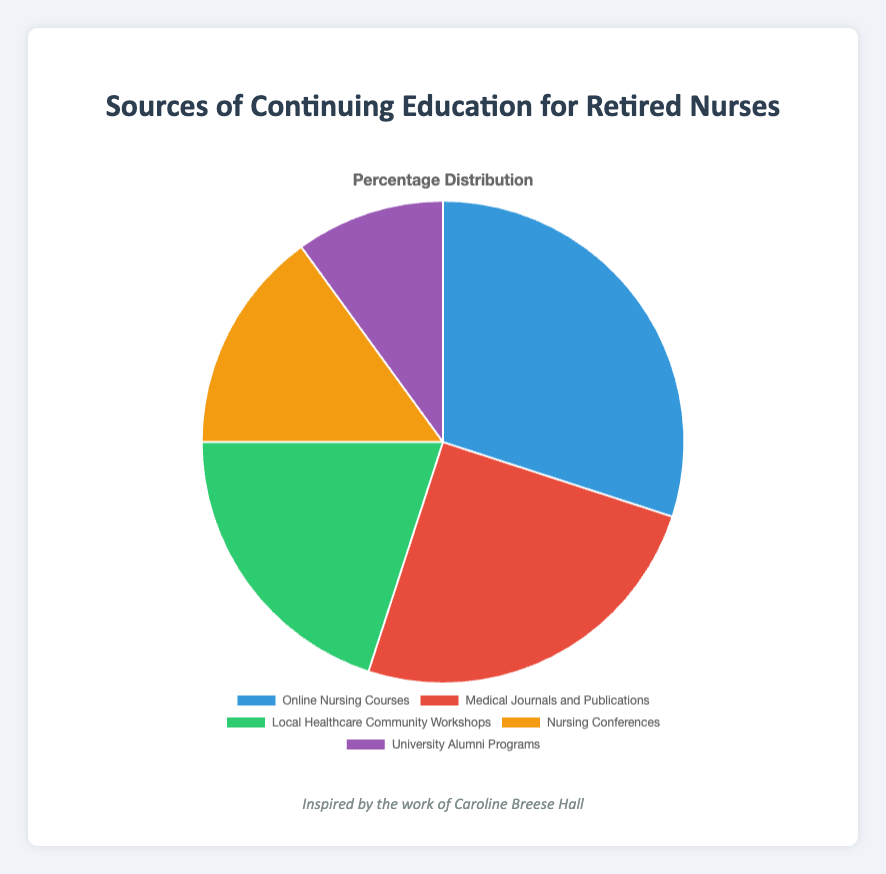What source has the highest percentage of continuing education for retired nurses? The source with the highest percentage can be identified by looking for the largest slice in the pie chart. "Online Nursing Courses" represents the largest segment with 30%.
Answer: Online Nursing Courses What is the percentage difference between "Online Nursing Courses" and "University Alumni Programs"? First, identify the percentages for both sources from the pie chart: "Online Nursing Courses" is 30% and "University Alumni Programs" is 10%. Subtract 10% from 30%, resulting in a difference of 20%.
Answer: 20% Which two sources combined have a total percentage of 35%? To find combinations that total 35%, look at the smaller segments. "Nursing Conferences" (15%) and "University Alumni Programs" (10%) combined make 25%. Combining "Medical Journals and Publications" (25%) with "University Alumni Programs" (10%) equals 35%.
Answer: Medical Journals and Publications and University Alumni Programs How much more popular are "Local Healthcare Community Workshops" compared to "Nursing Conferences"? From the pie chart, "Local Healthcare Community Workshops" is 20% and "Nursing Conferences" is 15%. Subtract 15% from 20% to get the difference of 5%.
Answer: 5% What color represents "Medical Journals and Publications"? The legend in the pie chart assigns colors to each category. The color next to "Medical Journals and Publications" is red.
Answer: Red What is the combined percentage of "Medical Journals and Publications" and "Online Nursing Courses"? Identify the percentages from the pie chart: "Medical Journals and Publications" is 25% and "Online Nursing Courses" is 30%. Summing these gives 55%.
Answer: 55% Which source occupies the smallest slice of the pie chart? The segment with the smallest percentage is the smallest slice in the pie chart. "University Alumni Programs" occupies the smallest slice with 10%.
Answer: University Alumni Programs Is the percentage of "Local Healthcare Community Workshops" more or less than "Medical Journals and Publications"? Comparing both percentages from the pie chart: "Local Healthcare Community Workshops" is 20% and "Medical Journals and Publications" is 25%. "Local Healthcare Community Workshops" is less than "Medical Journals and Publications".
Answer: Less What are the visual features used to distinguish "Nursing Conferences" in the pie chart? The pie chart uses color to distinguish categories. The legend shows that "Nursing Conferences" is represented by the color orange.
Answer: Orange 